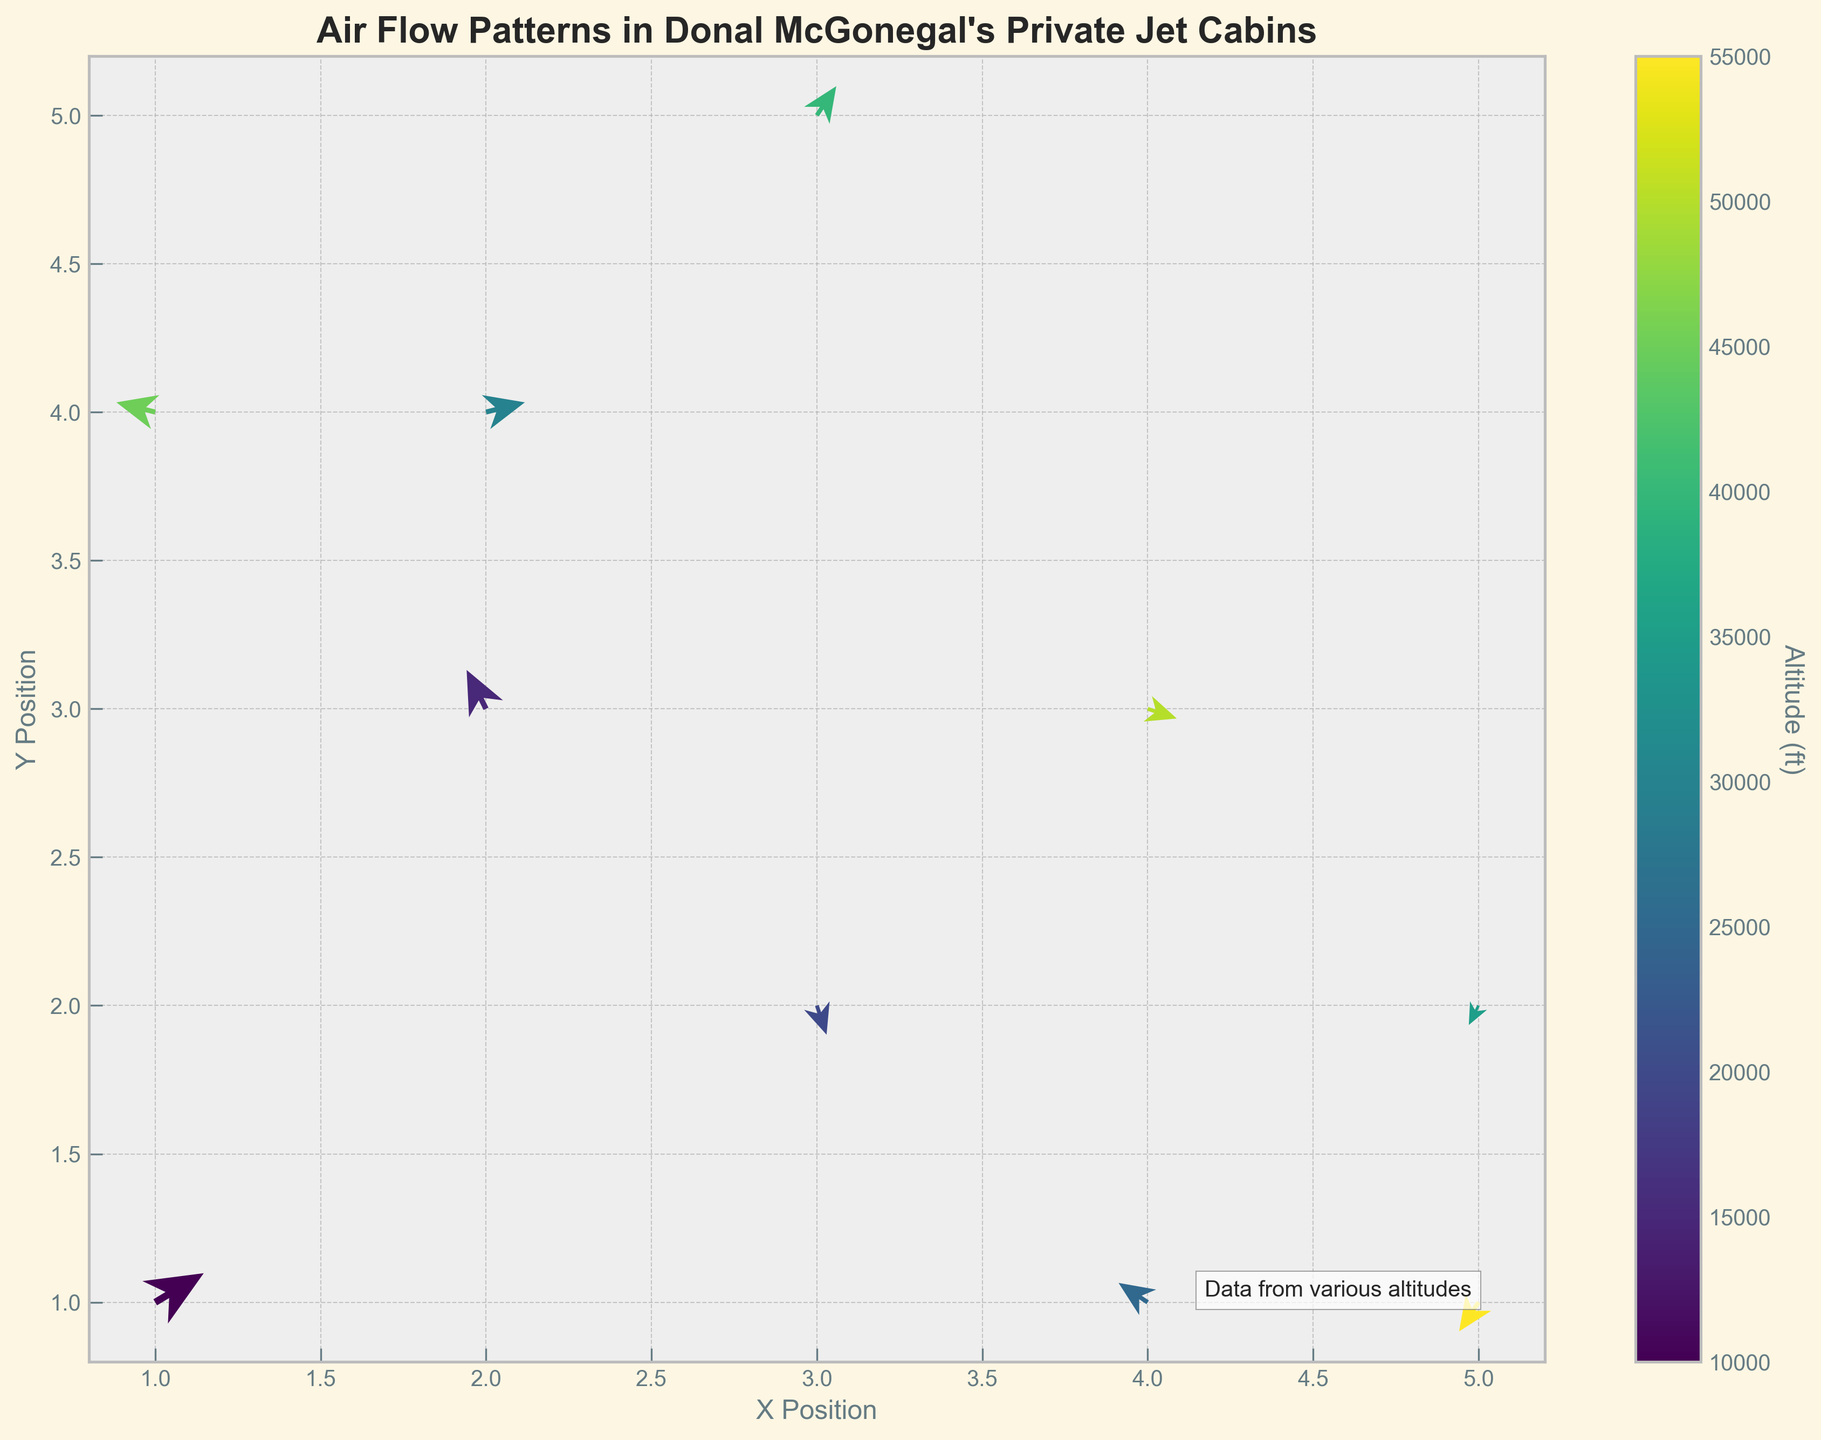What is the title of the figure? The title is displayed at the top of the plot.
Answer: Air Flow Patterns in Donal McGonegal's Private Jet Cabins What do the colors of the arrows represent? The colorbar next to the plot indicates that colors represent different altitudes in feet.
Answer: Different altitudes At which coordinates do we have the highest altitude? By looking at the color of the arrows and the colorbar, the brightest color corresponds to the highest altitude. The arrow at coordinates (3, 5) is the brightest.
Answer: (3, 5) What is the direction of the arrow at coordinates (1, 1)? The arrow at (1, 1) points slightly upward and to the right, indicating the airflow direction.
Answer: Up and right Which data point has an eastward airflow? Eastward airflow means the u-component should be positive. The arrow at (2, 4) has u=0.4, which is eastward.
Answer: (2, 4) Compare the airflow directionality at altitudes 45000 ft and 50000 ft. To compare, observe the arrow directions: (1, 4) at 45000 ft points mostly westward, (4, 3) at 50000 ft points mostly eastward.
Answer: Westward at 45000 ft, eastward at 50000 ft How many arrows point in the downward direction? Arrows pointing downward have a negative v-component. (1, 1) (3, 2) (5, 2) (4, 3) (5, 1) total 5 arrows.
Answer: 5 What is the average altitude shown in the plot? List the altitudes and sum them: 10000 + 15000 + 20000 + 25000 + 30000 + 35000 + 40000 + 45000 + 50000 + 55000 = 325000, divide by 10 data points.
Answer: 32500 ft Is airflow stronger at higher or lower altitudes based on the quiver plot? By observing the lengths of the arrows for various altitudes, arrows at higher altitudes seem shorter, indicating weaker airflow.
Answer: Lower altitudes What is the longest arrow in the diagram and at which altitude? Measure the length of all arrows: the arrow at (2, 4) with a magnitude of sqrt(0.4^2 + 0.1^2) = sqrt(0.17) is longest at 30000 ft.
Answer: (2, 4), 30000 ft 